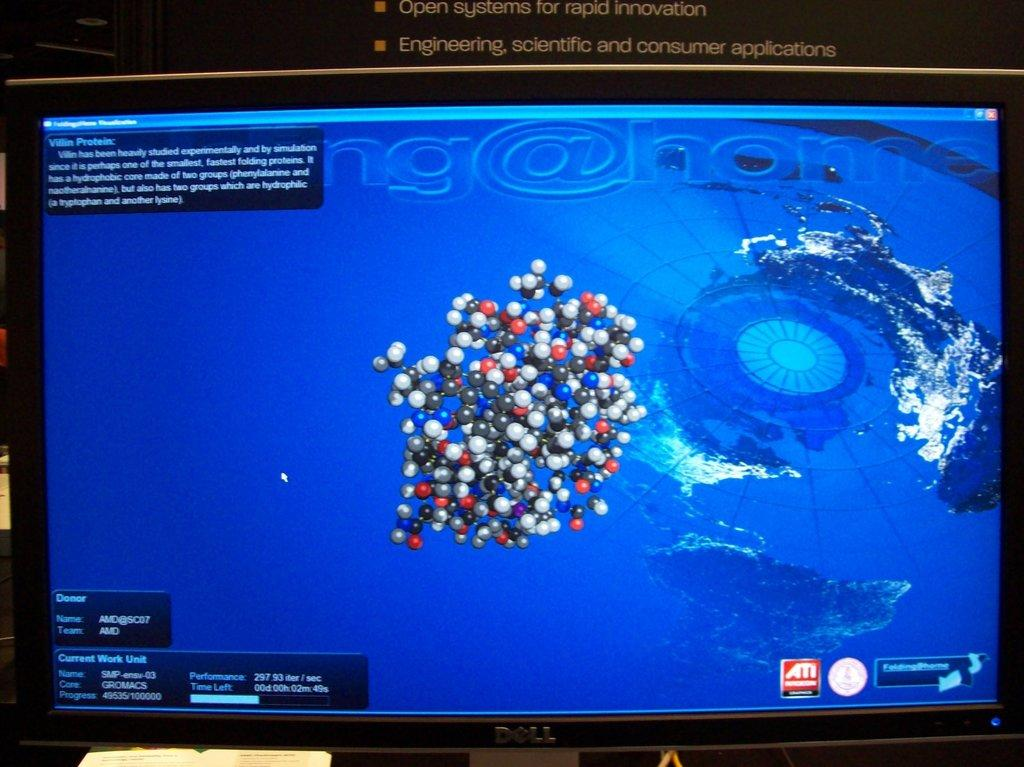What is the main object in the image? There is a monitor screen in the image. What type of scale can be seen next to the monitor screen in the image? There is no scale present in the image; only the monitor screen is mentioned in the provided fact. 